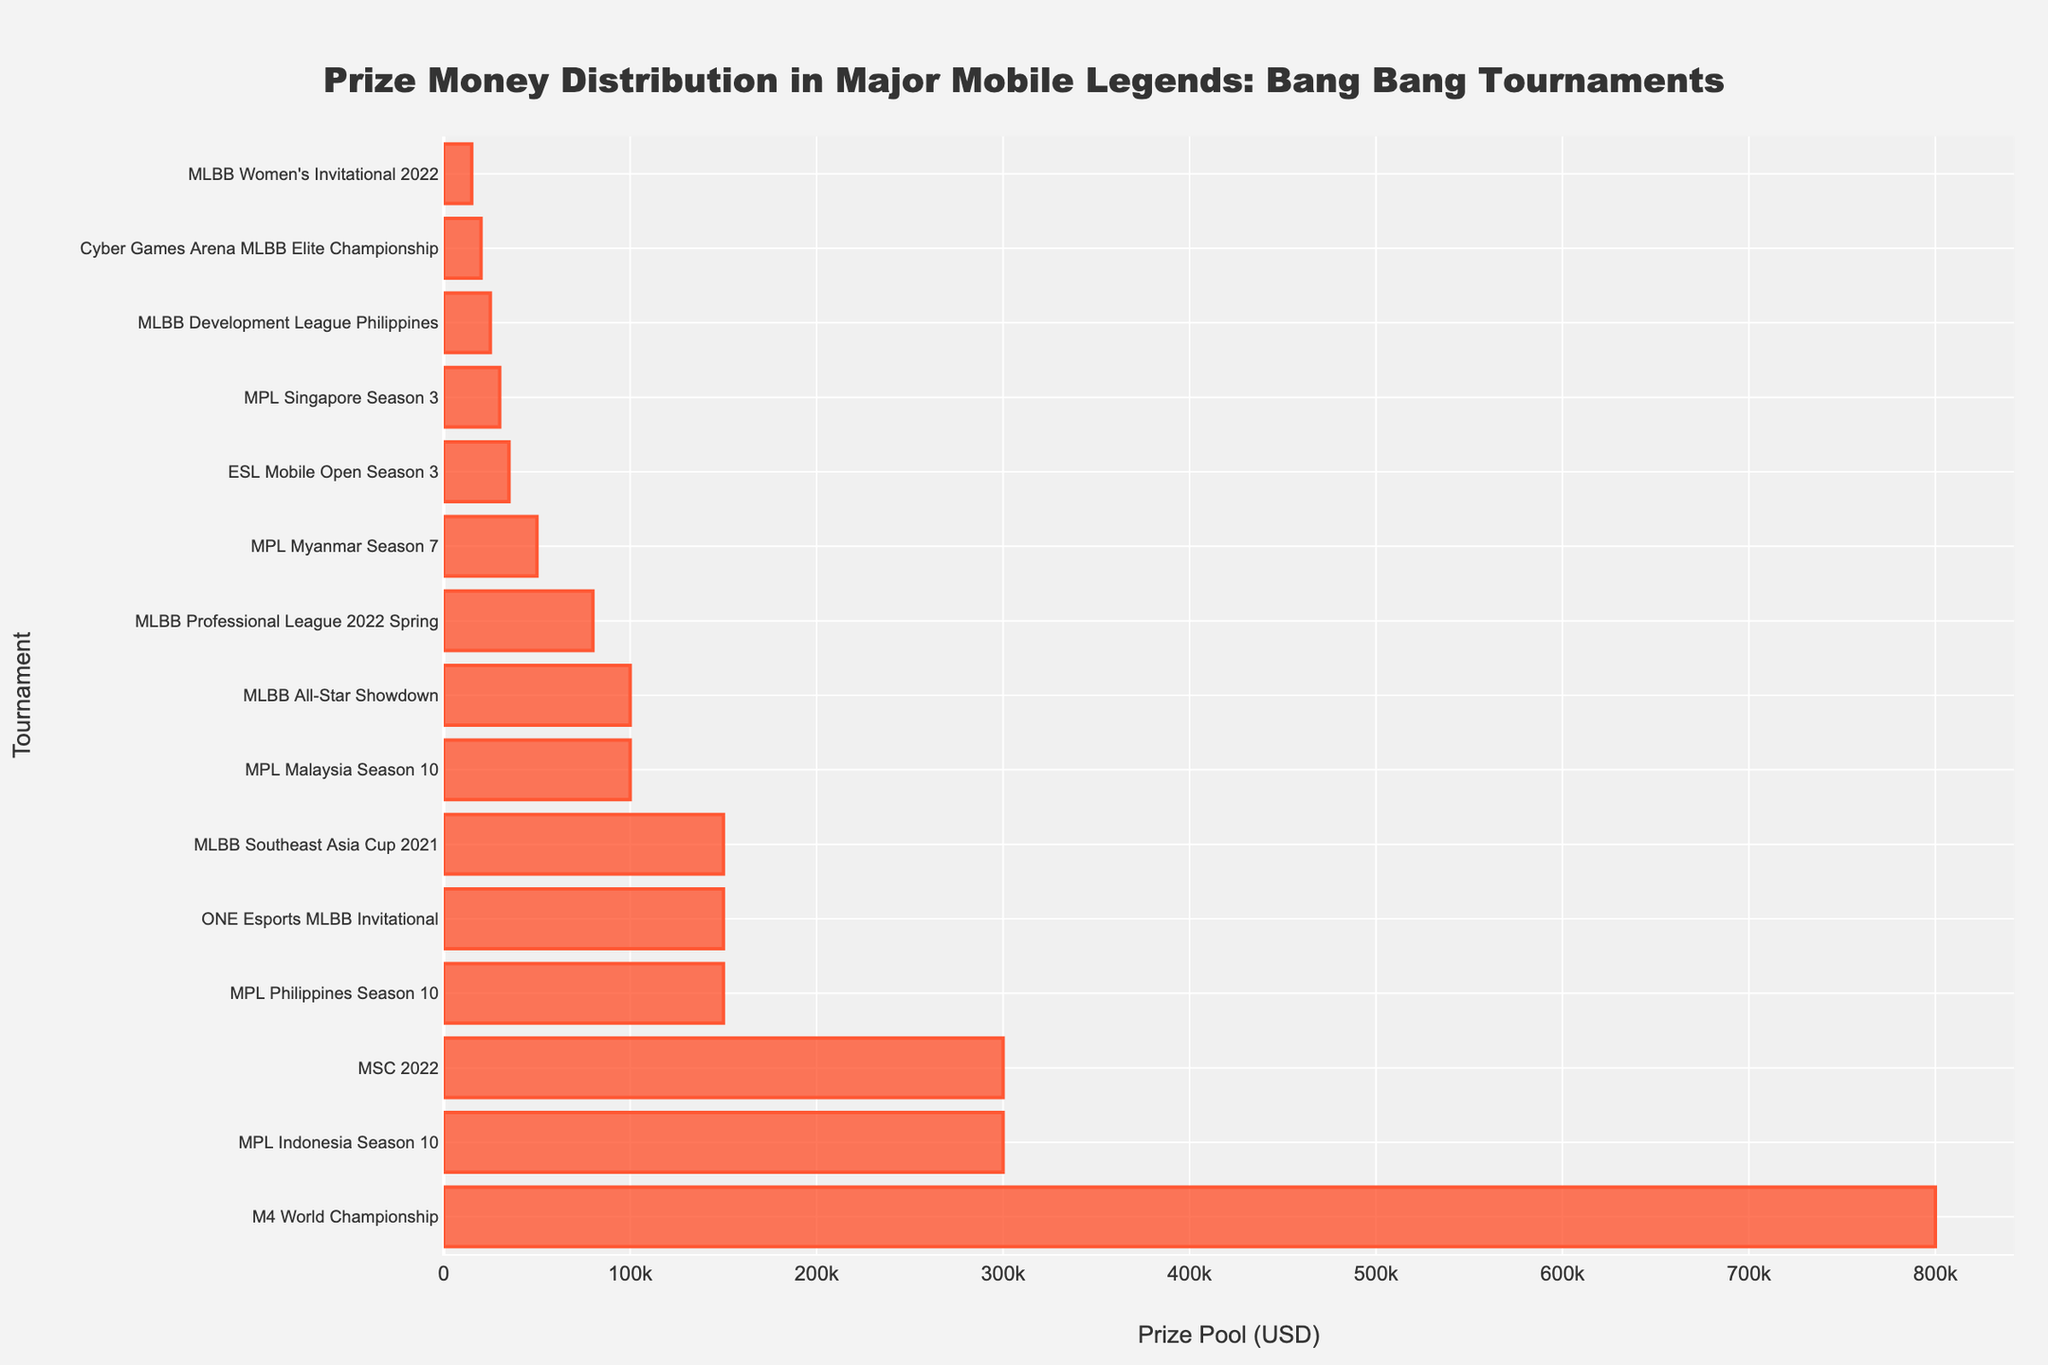Which tournament has the highest prize pool? The tournament with the highest prize pool can be determined by identifying the longest bar in the chart. The longest bar corresponds to the M4 World Championship.
Answer: M4 World Championship How many tournaments have prize pools of at least $100,000? Count the number of bars that extend to at least the $100,000 mark on the x-axis. These tournaments are M4 World Championship, MPL Indonesia Season 10, MSC 2022, MPL Philippines Season 10, ONE Esports MLBB Invitational, and MLBB All-Star Showdown.
Answer: 6 Which tournament has the lowest prize pool? Identify the shortest bar in the chart. The shortest bar corresponds to the MLBB Women's Invitational 2022.
Answer: MLBB Women's Invitational 2022 What is the combined prize pool of the MPL Indonesia Season 10 and MSC 2022 tournaments? The prize pool for MPL Indonesia Season 10 is $300,000, and for MSC 2022, it is also $300,000. Adding these values gives $300,000 + $300,000 = $600,000.
Answer: $600,000 What is the difference in prize pool between the M4 World Championship and MPL Philippines Season 10? The prize pool for M4 World Championship is $800,000, and for MPL Philippines Season 10, it is $150,000. The difference is $800,000 - $150,000 = $650,000.
Answer: $650,000 Are there more tournaments with a prize pool greater than $100,000 or less than $100,000? Count the number of bars longer than $100,000 and less than $100,000. There are 6 tournaments with greater than $100,000 and 8 tournaments with less than $100,000.
Answer: Less than $100,000 Which two tournaments have identical prize pools? Look for bars that are of equal length on the plot. MPL Indonesia Season 10 and MSC 2022 both have prize pools of $300,000.
Answer: MPL Indonesia Season 10 and MSC 2022 What is the average prize pool of all the tournaments listed? Sum the prize pools of all tournaments and divide by the total number of tournaments (15). \( \text{Sum} = 800,000 + 300,000 + 300,000 + 150,000 + 150,000 + 100,000 + 150,000 + 50,000 + 80,000 + 35,000 + 100,000 + 30,000 + 15,000 + 25,000 + 20,000 = 2,305,000 \) The average is \( 2,305,000 / 15 \approx 153,667 \).
Answer: $153,667 